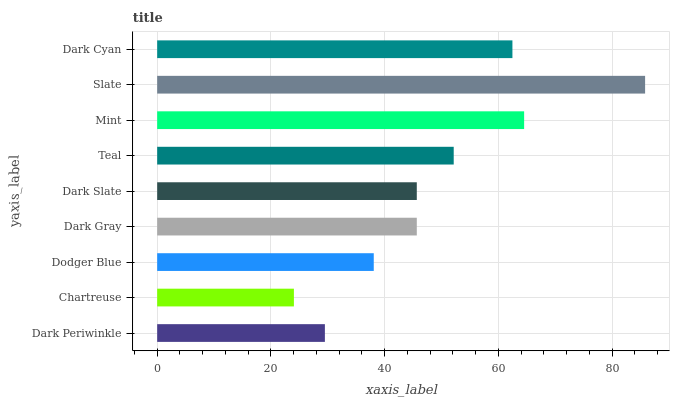Is Chartreuse the minimum?
Answer yes or no. Yes. Is Slate the maximum?
Answer yes or no. Yes. Is Dodger Blue the minimum?
Answer yes or no. No. Is Dodger Blue the maximum?
Answer yes or no. No. Is Dodger Blue greater than Chartreuse?
Answer yes or no. Yes. Is Chartreuse less than Dodger Blue?
Answer yes or no. Yes. Is Chartreuse greater than Dodger Blue?
Answer yes or no. No. Is Dodger Blue less than Chartreuse?
Answer yes or no. No. Is Dark Gray the high median?
Answer yes or no. Yes. Is Dark Gray the low median?
Answer yes or no. Yes. Is Slate the high median?
Answer yes or no. No. Is Mint the low median?
Answer yes or no. No. 